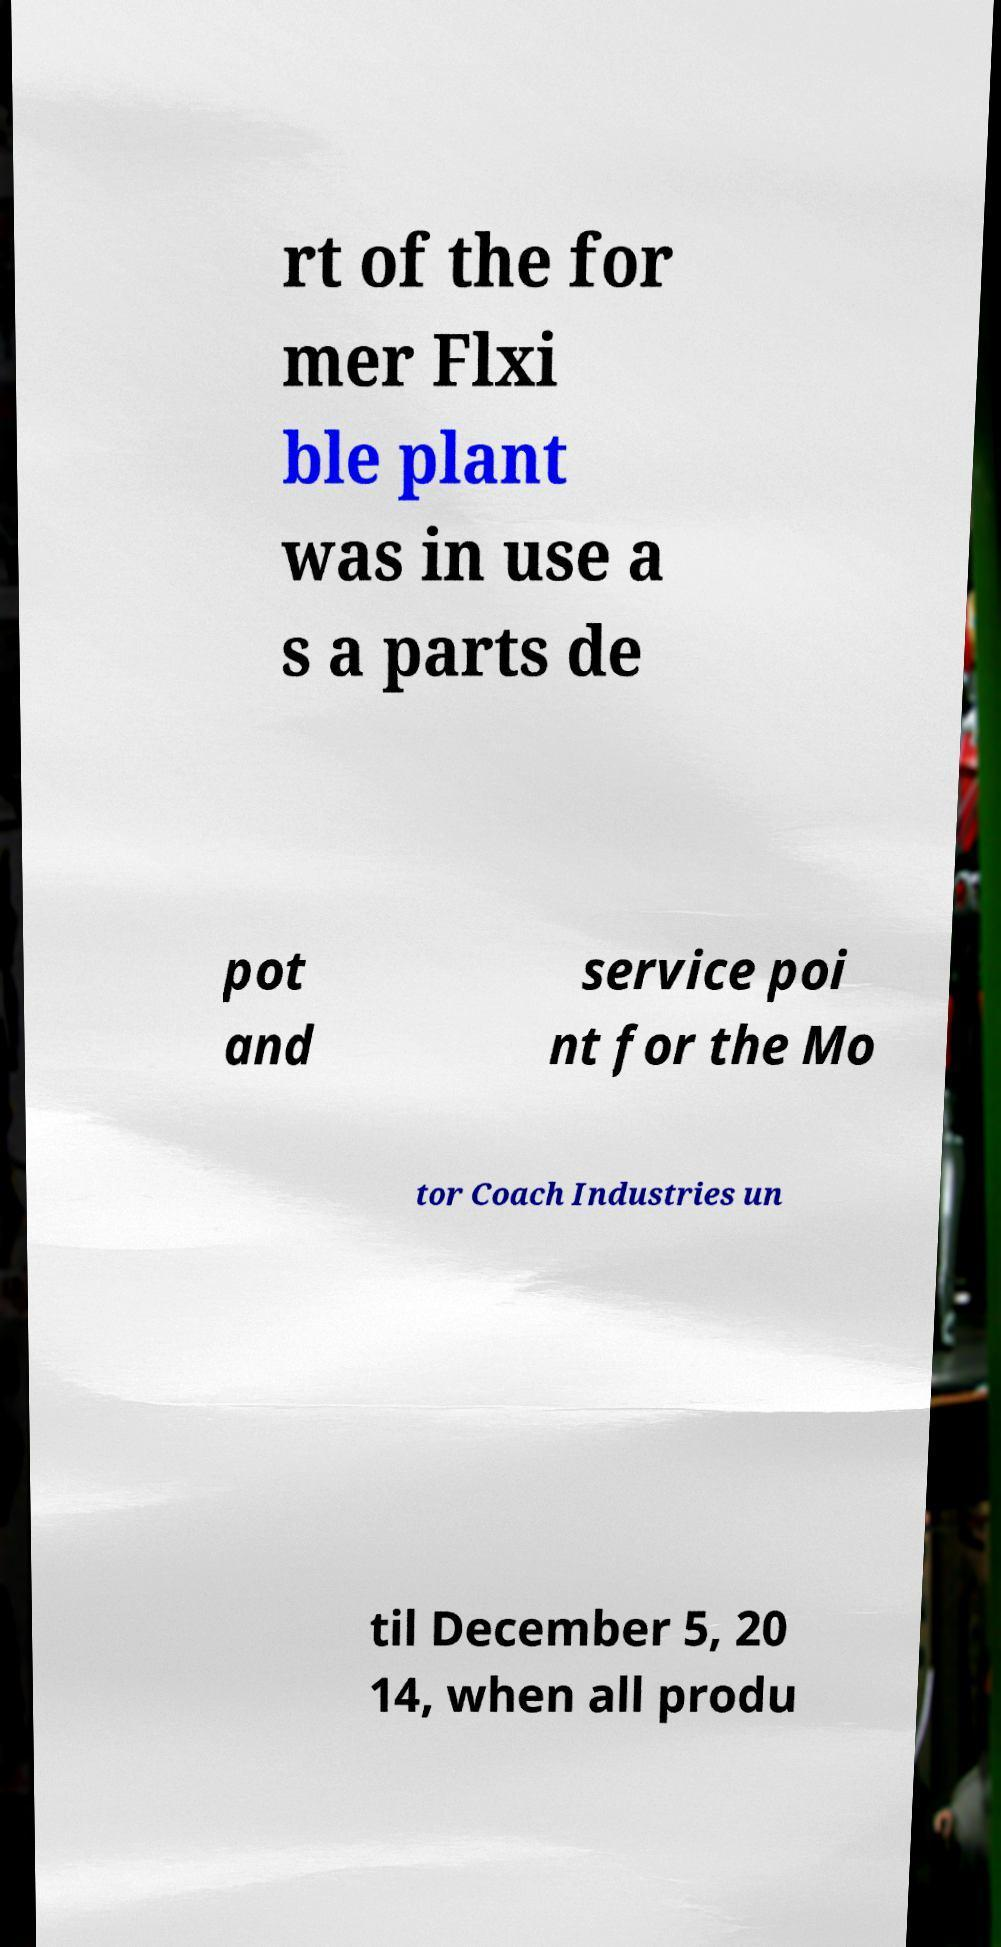Can you read and provide the text displayed in the image?This photo seems to have some interesting text. Can you extract and type it out for me? rt of the for mer Flxi ble plant was in use a s a parts de pot and service poi nt for the Mo tor Coach Industries un til December 5, 20 14, when all produ 